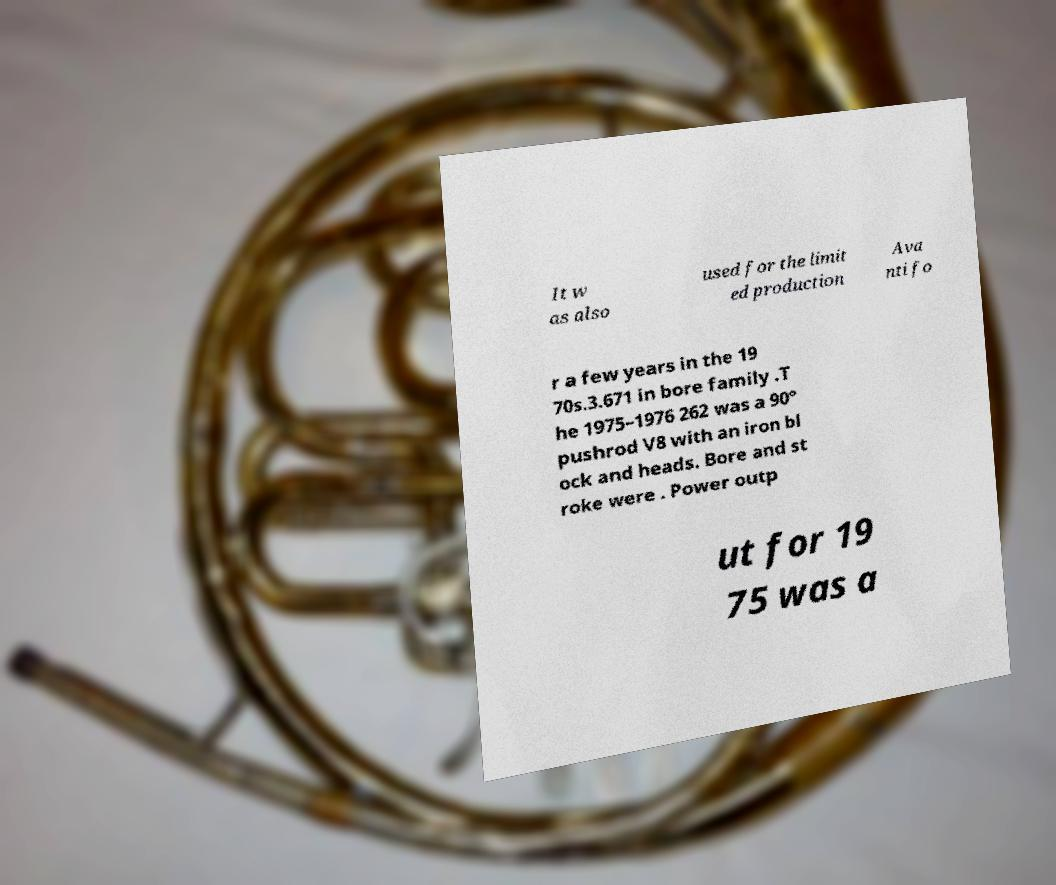Can you accurately transcribe the text from the provided image for me? It w as also used for the limit ed production Ava nti fo r a few years in the 19 70s.3.671 in bore family .T he 1975–1976 262 was a 90° pushrod V8 with an iron bl ock and heads. Bore and st roke were . Power outp ut for 19 75 was a 